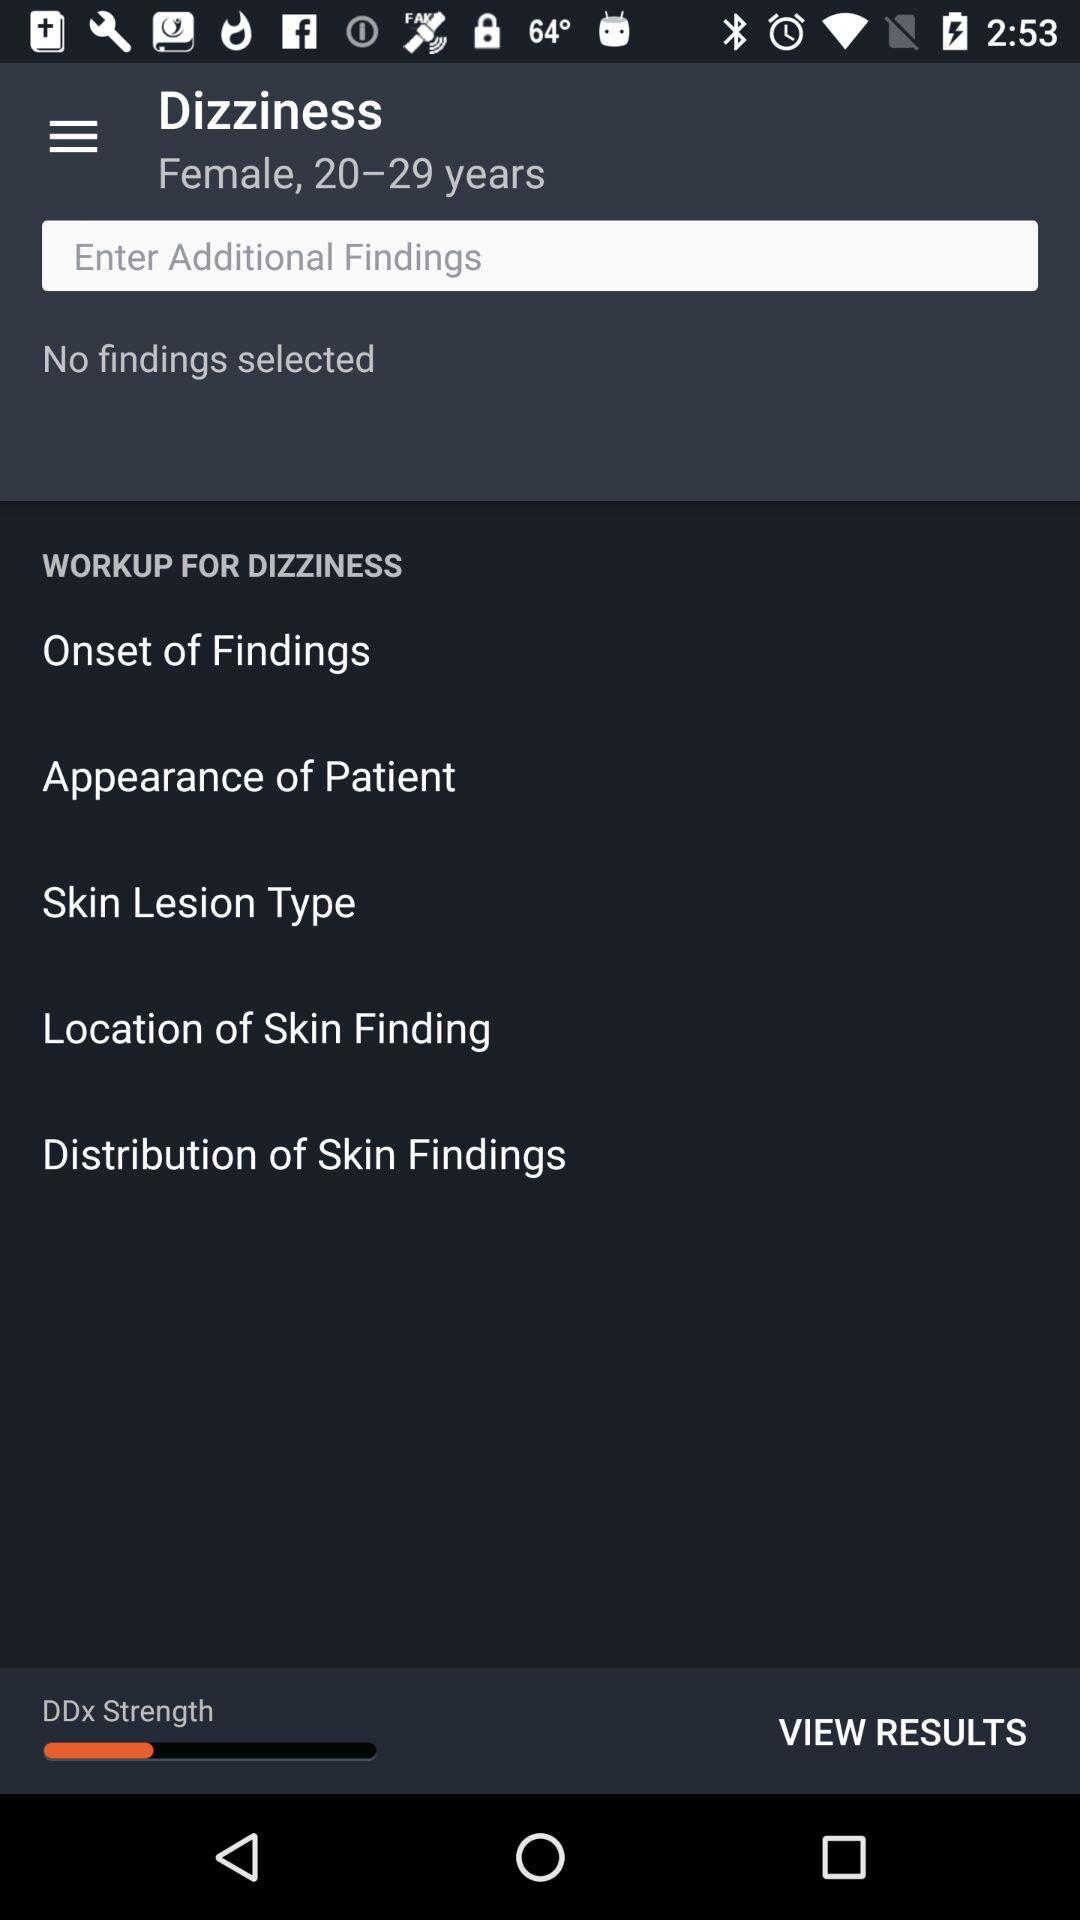What is the age range? The age range is 20 to 29 years old. 